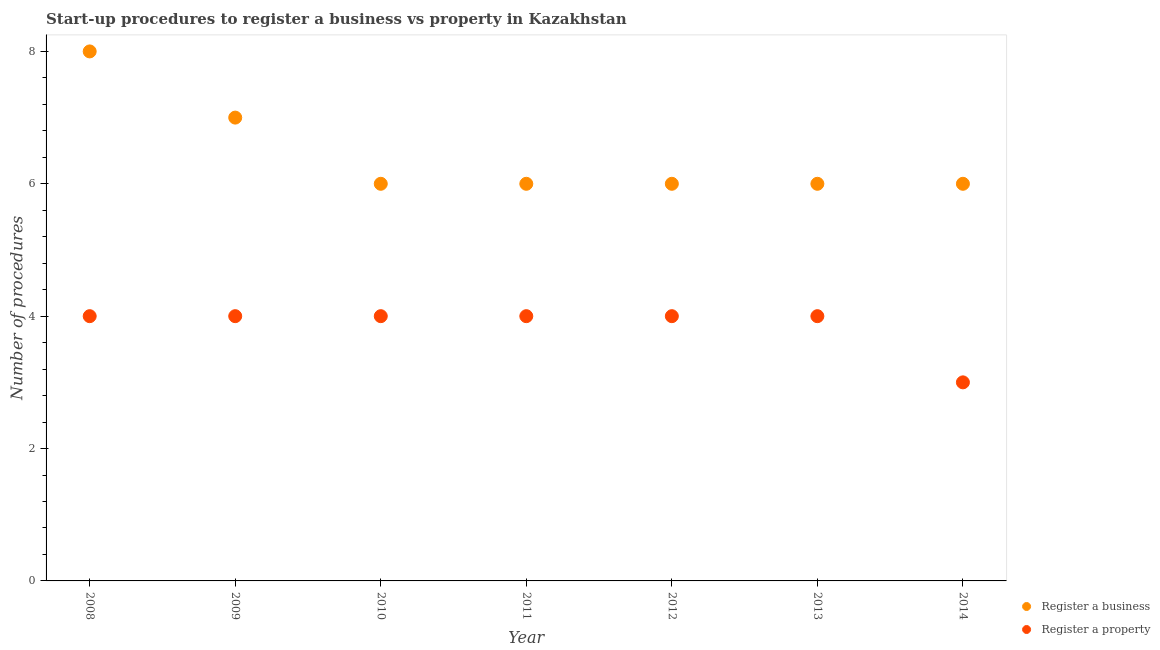Is the number of dotlines equal to the number of legend labels?
Your answer should be compact. Yes. Across all years, what is the maximum number of procedures to register a property?
Make the answer very short. 4. Across all years, what is the minimum number of procedures to register a business?
Give a very brief answer. 6. In which year was the number of procedures to register a business maximum?
Ensure brevity in your answer.  2008. What is the total number of procedures to register a property in the graph?
Offer a terse response. 27. What is the difference between the number of procedures to register a business in 2013 and the number of procedures to register a property in 2008?
Give a very brief answer. 2. What is the average number of procedures to register a business per year?
Keep it short and to the point. 6.43. In the year 2011, what is the difference between the number of procedures to register a property and number of procedures to register a business?
Keep it short and to the point. -2. What is the ratio of the number of procedures to register a property in 2009 to that in 2012?
Keep it short and to the point. 1. Is the number of procedures to register a business in 2011 less than that in 2014?
Your response must be concise. No. Is the difference between the number of procedures to register a property in 2012 and 2014 greater than the difference between the number of procedures to register a business in 2012 and 2014?
Your response must be concise. Yes. What is the difference between the highest and the second highest number of procedures to register a business?
Offer a terse response. 1. What is the difference between the highest and the lowest number of procedures to register a property?
Provide a short and direct response. 1. In how many years, is the number of procedures to register a business greater than the average number of procedures to register a business taken over all years?
Ensure brevity in your answer.  2. Is the sum of the number of procedures to register a business in 2008 and 2013 greater than the maximum number of procedures to register a property across all years?
Provide a succinct answer. Yes. Does the number of procedures to register a business monotonically increase over the years?
Ensure brevity in your answer.  No. Is the number of procedures to register a property strictly greater than the number of procedures to register a business over the years?
Keep it short and to the point. No. Is the number of procedures to register a property strictly less than the number of procedures to register a business over the years?
Give a very brief answer. Yes. How many dotlines are there?
Make the answer very short. 2. What is the difference between two consecutive major ticks on the Y-axis?
Your answer should be compact. 2. Where does the legend appear in the graph?
Offer a terse response. Bottom right. What is the title of the graph?
Provide a short and direct response. Start-up procedures to register a business vs property in Kazakhstan. Does "Primary education" appear as one of the legend labels in the graph?
Offer a very short reply. No. What is the label or title of the X-axis?
Provide a succinct answer. Year. What is the label or title of the Y-axis?
Make the answer very short. Number of procedures. What is the Number of procedures of Register a business in 2008?
Your answer should be very brief. 8. What is the Number of procedures of Register a property in 2008?
Your answer should be compact. 4. What is the Number of procedures of Register a property in 2010?
Your answer should be compact. 4. What is the Number of procedures in Register a business in 2013?
Ensure brevity in your answer.  6. What is the Number of procedures in Register a property in 2013?
Offer a terse response. 4. What is the Number of procedures in Register a business in 2014?
Your answer should be compact. 6. What is the Number of procedures of Register a property in 2014?
Your answer should be very brief. 3. Across all years, what is the maximum Number of procedures of Register a business?
Your response must be concise. 8. Across all years, what is the minimum Number of procedures of Register a business?
Give a very brief answer. 6. What is the total Number of procedures of Register a property in the graph?
Ensure brevity in your answer.  27. What is the difference between the Number of procedures in Register a business in 2008 and that in 2009?
Give a very brief answer. 1. What is the difference between the Number of procedures of Register a property in 2008 and that in 2009?
Offer a very short reply. 0. What is the difference between the Number of procedures of Register a business in 2008 and that in 2012?
Offer a very short reply. 2. What is the difference between the Number of procedures of Register a business in 2008 and that in 2013?
Ensure brevity in your answer.  2. What is the difference between the Number of procedures of Register a business in 2008 and that in 2014?
Offer a terse response. 2. What is the difference between the Number of procedures of Register a business in 2009 and that in 2011?
Ensure brevity in your answer.  1. What is the difference between the Number of procedures of Register a property in 2009 and that in 2011?
Ensure brevity in your answer.  0. What is the difference between the Number of procedures in Register a business in 2009 and that in 2013?
Ensure brevity in your answer.  1. What is the difference between the Number of procedures in Register a property in 2009 and that in 2013?
Make the answer very short. 0. What is the difference between the Number of procedures in Register a property in 2009 and that in 2014?
Your answer should be very brief. 1. What is the difference between the Number of procedures of Register a property in 2010 and that in 2012?
Your response must be concise. 0. What is the difference between the Number of procedures of Register a property in 2010 and that in 2013?
Your answer should be very brief. 0. What is the difference between the Number of procedures of Register a property in 2011 and that in 2012?
Ensure brevity in your answer.  0. What is the difference between the Number of procedures in Register a business in 2011 and that in 2013?
Provide a short and direct response. 0. What is the difference between the Number of procedures in Register a property in 2012 and that in 2013?
Your response must be concise. 0. What is the difference between the Number of procedures in Register a business in 2012 and that in 2014?
Keep it short and to the point. 0. What is the difference between the Number of procedures in Register a property in 2013 and that in 2014?
Keep it short and to the point. 1. What is the difference between the Number of procedures of Register a business in 2008 and the Number of procedures of Register a property in 2013?
Offer a very short reply. 4. What is the difference between the Number of procedures in Register a business in 2009 and the Number of procedures in Register a property in 2010?
Your answer should be compact. 3. What is the difference between the Number of procedures of Register a business in 2009 and the Number of procedures of Register a property in 2012?
Make the answer very short. 3. What is the difference between the Number of procedures in Register a business in 2009 and the Number of procedures in Register a property in 2014?
Provide a short and direct response. 4. What is the difference between the Number of procedures in Register a business in 2010 and the Number of procedures in Register a property in 2011?
Your answer should be very brief. 2. What is the difference between the Number of procedures of Register a business in 2010 and the Number of procedures of Register a property in 2013?
Ensure brevity in your answer.  2. What is the difference between the Number of procedures in Register a business in 2010 and the Number of procedures in Register a property in 2014?
Provide a succinct answer. 3. What is the difference between the Number of procedures of Register a business in 2011 and the Number of procedures of Register a property in 2012?
Keep it short and to the point. 2. What is the difference between the Number of procedures of Register a business in 2011 and the Number of procedures of Register a property in 2013?
Keep it short and to the point. 2. What is the average Number of procedures in Register a business per year?
Your response must be concise. 6.43. What is the average Number of procedures in Register a property per year?
Offer a very short reply. 3.86. In the year 2008, what is the difference between the Number of procedures in Register a business and Number of procedures in Register a property?
Your response must be concise. 4. In the year 2009, what is the difference between the Number of procedures of Register a business and Number of procedures of Register a property?
Provide a short and direct response. 3. In the year 2010, what is the difference between the Number of procedures in Register a business and Number of procedures in Register a property?
Provide a short and direct response. 2. In the year 2011, what is the difference between the Number of procedures of Register a business and Number of procedures of Register a property?
Ensure brevity in your answer.  2. In the year 2013, what is the difference between the Number of procedures of Register a business and Number of procedures of Register a property?
Offer a very short reply. 2. What is the ratio of the Number of procedures of Register a business in 2008 to that in 2009?
Ensure brevity in your answer.  1.14. What is the ratio of the Number of procedures in Register a property in 2008 to that in 2011?
Provide a succinct answer. 1. What is the ratio of the Number of procedures in Register a business in 2008 to that in 2012?
Your response must be concise. 1.33. What is the ratio of the Number of procedures in Register a business in 2008 to that in 2013?
Make the answer very short. 1.33. What is the ratio of the Number of procedures of Register a business in 2009 to that in 2010?
Give a very brief answer. 1.17. What is the ratio of the Number of procedures of Register a business in 2009 to that in 2014?
Offer a very short reply. 1.17. What is the ratio of the Number of procedures in Register a property in 2009 to that in 2014?
Your answer should be very brief. 1.33. What is the ratio of the Number of procedures of Register a business in 2010 to that in 2011?
Your answer should be very brief. 1. What is the ratio of the Number of procedures in Register a property in 2010 to that in 2011?
Give a very brief answer. 1. What is the ratio of the Number of procedures in Register a property in 2010 to that in 2012?
Give a very brief answer. 1. What is the ratio of the Number of procedures in Register a property in 2010 to that in 2014?
Provide a succinct answer. 1.33. What is the ratio of the Number of procedures in Register a business in 2011 to that in 2012?
Your response must be concise. 1. What is the ratio of the Number of procedures of Register a property in 2011 to that in 2012?
Provide a short and direct response. 1. What is the ratio of the Number of procedures in Register a business in 2011 to that in 2013?
Offer a terse response. 1. What is the ratio of the Number of procedures of Register a property in 2011 to that in 2013?
Offer a terse response. 1. What is the ratio of the Number of procedures in Register a property in 2011 to that in 2014?
Offer a very short reply. 1.33. What is the ratio of the Number of procedures of Register a business in 2012 to that in 2014?
Offer a very short reply. 1. What is the difference between the highest and the second highest Number of procedures of Register a business?
Ensure brevity in your answer.  1. What is the difference between the highest and the second highest Number of procedures of Register a property?
Offer a very short reply. 0. 